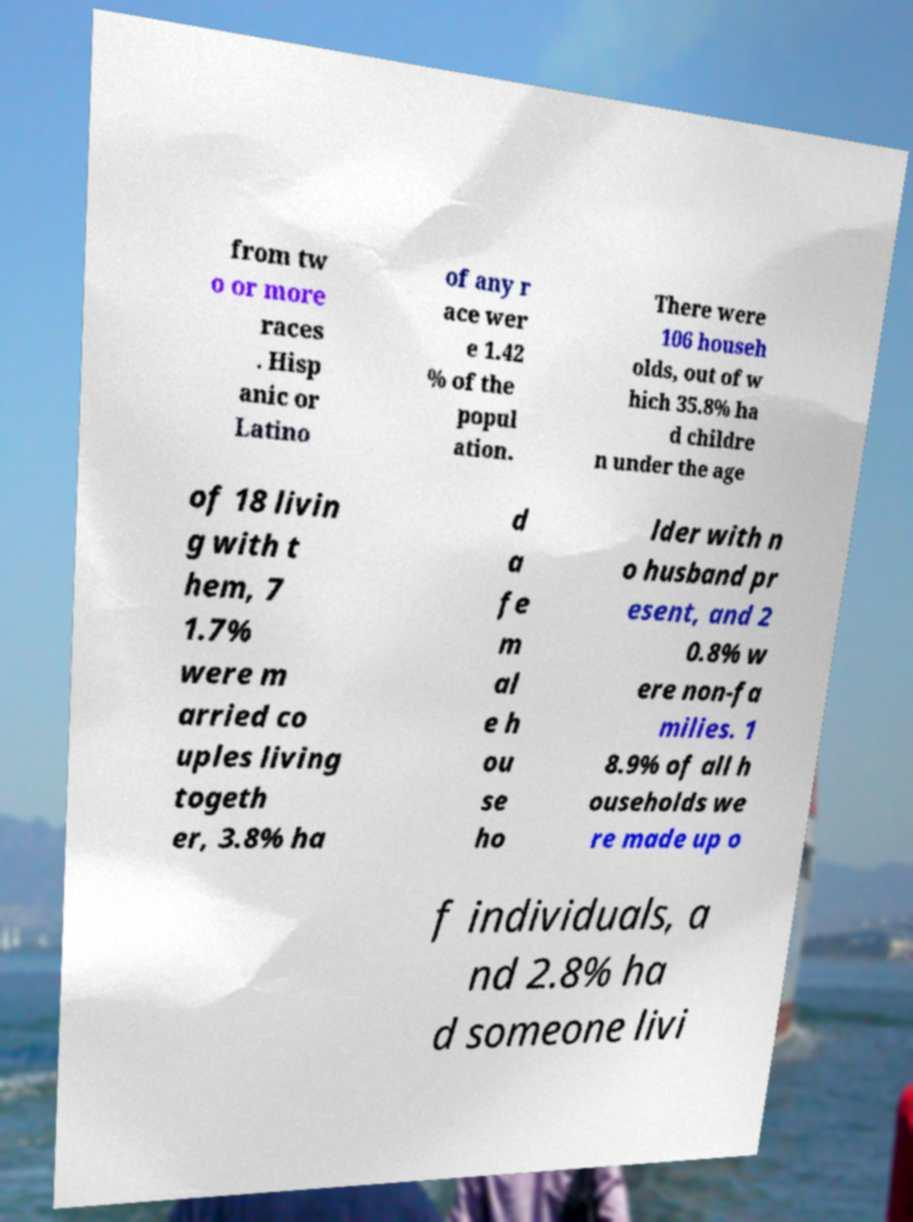Can you accurately transcribe the text from the provided image for me? from tw o or more races . Hisp anic or Latino of any r ace wer e 1.42 % of the popul ation. There were 106 househ olds, out of w hich 35.8% ha d childre n under the age of 18 livin g with t hem, 7 1.7% were m arried co uples living togeth er, 3.8% ha d a fe m al e h ou se ho lder with n o husband pr esent, and 2 0.8% w ere non-fa milies. 1 8.9% of all h ouseholds we re made up o f individuals, a nd 2.8% ha d someone livi 